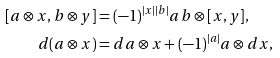<formula> <loc_0><loc_0><loc_500><loc_500>[ a \otimes x , b \otimes y ] & = ( - 1 ) ^ { | x | | b | } a b \otimes [ x , y ] , \\ d ( a \otimes x ) & = d a \otimes x + ( - 1 ) ^ { | a | } a \otimes d x ,</formula> 